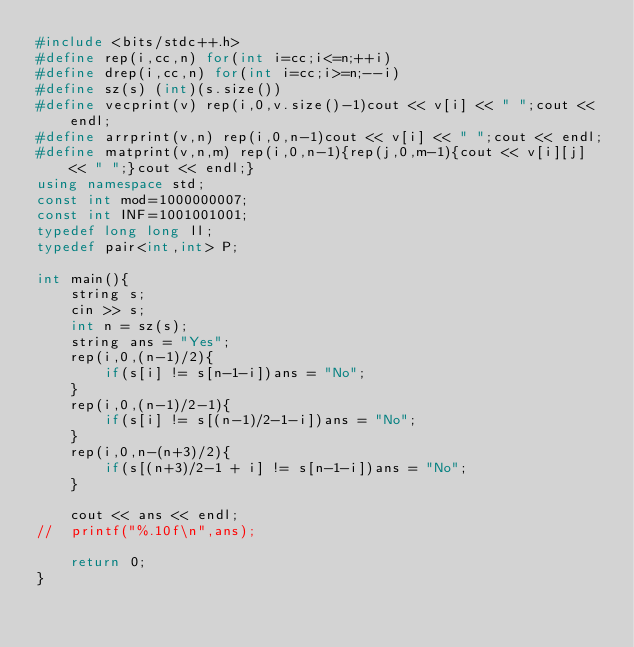Convert code to text. <code><loc_0><loc_0><loc_500><loc_500><_C++_>#include <bits/stdc++.h>
#define rep(i,cc,n) for(int i=cc;i<=n;++i)
#define drep(i,cc,n) for(int i=cc;i>=n;--i)
#define sz(s) (int)(s.size())
#define vecprint(v) rep(i,0,v.size()-1)cout << v[i] << " ";cout << endl;
#define arrprint(v,n) rep(i,0,n-1)cout << v[i] << " ";cout << endl;
#define matprint(v,n,m) rep(i,0,n-1){rep(j,0,m-1){cout << v[i][j] << " ";}cout << endl;}
using namespace std;
const int mod=1000000007;
const int INF=1001001001;
typedef long long ll;
typedef pair<int,int> P;

int main(){
    string s;
    cin >> s;
    int n = sz(s);
    string ans = "Yes";
    rep(i,0,(n-1)/2){
        if(s[i] != s[n-1-i])ans = "No";
    }
    rep(i,0,(n-1)/2-1){
        if(s[i] != s[(n-1)/2-1-i])ans = "No";
    }
    rep(i,0,n-(n+3)/2){
        if(s[(n+3)/2-1 + i] != s[n-1-i])ans = "No";
    }

    cout << ans << endl;
//  printf("%.10f\n",ans);

    return 0;
}</code> 